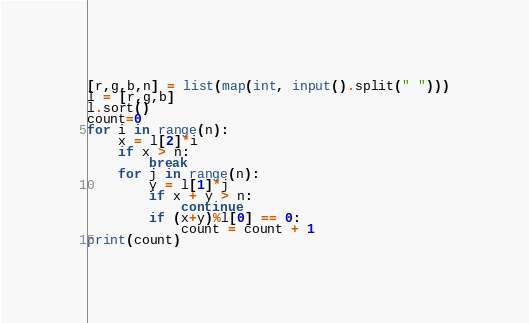Convert code to text. <code><loc_0><loc_0><loc_500><loc_500><_Python_>[r,g,b,n] = list(map(int, input().split(" ")))
l = [r,g,b]
l.sort()
count=0
for i in range(n):
    x = l[2]*i
    if x > n:
        break
    for j in range(n):
        y = l[1]*j
        if x + y > n:
            continue
        if (x+y)%l[0] == 0:
            count = count + 1
print(count)</code> 